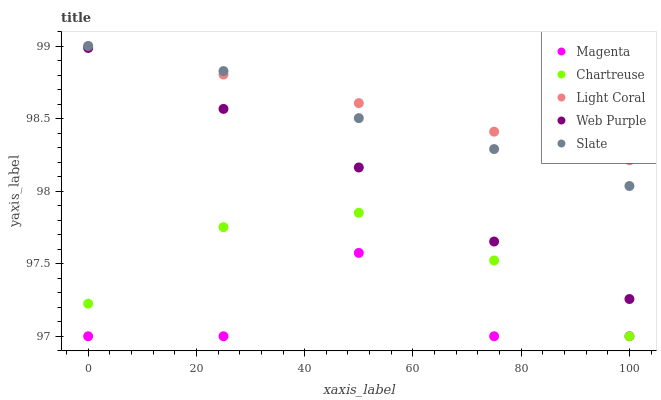Does Magenta have the minimum area under the curve?
Answer yes or no. Yes. Does Light Coral have the maximum area under the curve?
Answer yes or no. Yes. Does Web Purple have the minimum area under the curve?
Answer yes or no. No. Does Web Purple have the maximum area under the curve?
Answer yes or no. No. Is Light Coral the smoothest?
Answer yes or no. Yes. Is Magenta the roughest?
Answer yes or no. Yes. Is Web Purple the smoothest?
Answer yes or no. No. Is Web Purple the roughest?
Answer yes or no. No. Does Magenta have the lowest value?
Answer yes or no. Yes. Does Web Purple have the lowest value?
Answer yes or no. No. Does Slate have the highest value?
Answer yes or no. Yes. Does Web Purple have the highest value?
Answer yes or no. No. Is Chartreuse less than Web Purple?
Answer yes or no. Yes. Is Light Coral greater than Chartreuse?
Answer yes or no. Yes. Does Magenta intersect Chartreuse?
Answer yes or no. Yes. Is Magenta less than Chartreuse?
Answer yes or no. No. Is Magenta greater than Chartreuse?
Answer yes or no. No. Does Chartreuse intersect Web Purple?
Answer yes or no. No. 